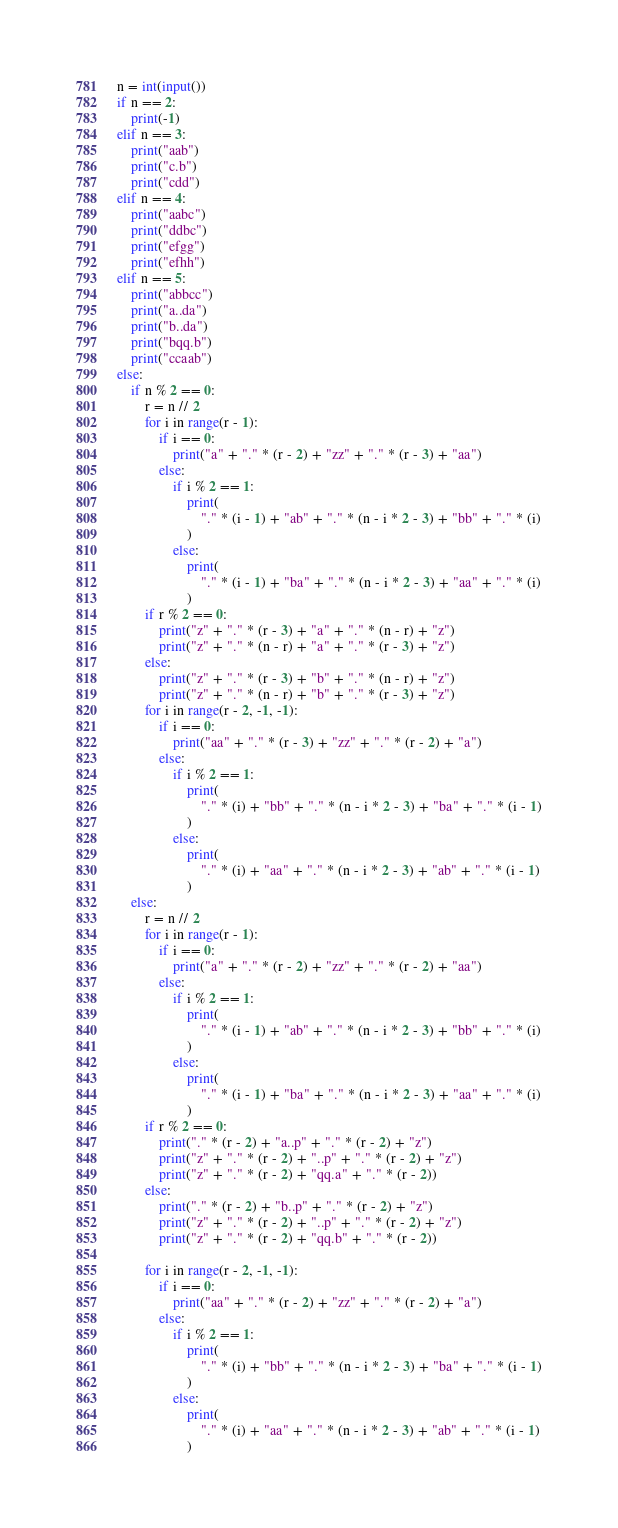Convert code to text. <code><loc_0><loc_0><loc_500><loc_500><_Python_>n = int(input())
if n == 2:
    print(-1)
elif n == 3:
    print("aab")
    print("c.b")
    print("cdd")
elif n == 4:
    print("aabc")
    print("ddbc")
    print("efgg")
    print("efhh")
elif n == 5:
    print("abbcc")
    print("a..da")
    print("b..da")
    print("bqq.b")
    print("ccaab")
else:
    if n % 2 == 0:
        r = n // 2
        for i in range(r - 1):
            if i == 0:
                print("a" + "." * (r - 2) + "zz" + "." * (r - 3) + "aa")
            else:
                if i % 2 == 1:
                    print(
                        "." * (i - 1) + "ab" + "." * (n - i * 2 - 3) + "bb" + "." * (i)
                    )
                else:
                    print(
                        "." * (i - 1) + "ba" + "." * (n - i * 2 - 3) + "aa" + "." * (i)
                    )
        if r % 2 == 0:
            print("z" + "." * (r - 3) + "a" + "." * (n - r) + "z")
            print("z" + "." * (n - r) + "a" + "." * (r - 3) + "z")
        else:
            print("z" + "." * (r - 3) + "b" + "." * (n - r) + "z")
            print("z" + "." * (n - r) + "b" + "." * (r - 3) + "z")
        for i in range(r - 2, -1, -1):
            if i == 0:
                print("aa" + "." * (r - 3) + "zz" + "." * (r - 2) + "a")
            else:
                if i % 2 == 1:
                    print(
                        "." * (i) + "bb" + "." * (n - i * 2 - 3) + "ba" + "." * (i - 1)
                    )
                else:
                    print(
                        "." * (i) + "aa" + "." * (n - i * 2 - 3) + "ab" + "." * (i - 1)
                    )
    else:
        r = n // 2
        for i in range(r - 1):
            if i == 0:
                print("a" + "." * (r - 2) + "zz" + "." * (r - 2) + "aa")
            else:
                if i % 2 == 1:
                    print(
                        "." * (i - 1) + "ab" + "." * (n - i * 2 - 3) + "bb" + "." * (i)
                    )
                else:
                    print(
                        "." * (i - 1) + "ba" + "." * (n - i * 2 - 3) + "aa" + "." * (i)
                    )
        if r % 2 == 0:
            print("." * (r - 2) + "a..p" + "." * (r - 2) + "z")
            print("z" + "." * (r - 2) + "..p" + "." * (r - 2) + "z")
            print("z" + "." * (r - 2) + "qq.a" + "." * (r - 2))
        else:
            print("." * (r - 2) + "b..p" + "." * (r - 2) + "z")
            print("z" + "." * (r - 2) + "..p" + "." * (r - 2) + "z")
            print("z" + "." * (r - 2) + "qq.b" + "." * (r - 2))

        for i in range(r - 2, -1, -1):
            if i == 0:
                print("aa" + "." * (r - 2) + "zz" + "." * (r - 2) + "a")
            else:
                if i % 2 == 1:
                    print(
                        "." * (i) + "bb" + "." * (n - i * 2 - 3) + "ba" + "." * (i - 1)
                    )
                else:
                    print(
                        "." * (i) + "aa" + "." * (n - i * 2 - 3) + "ab" + "." * (i - 1)
                    )
</code> 